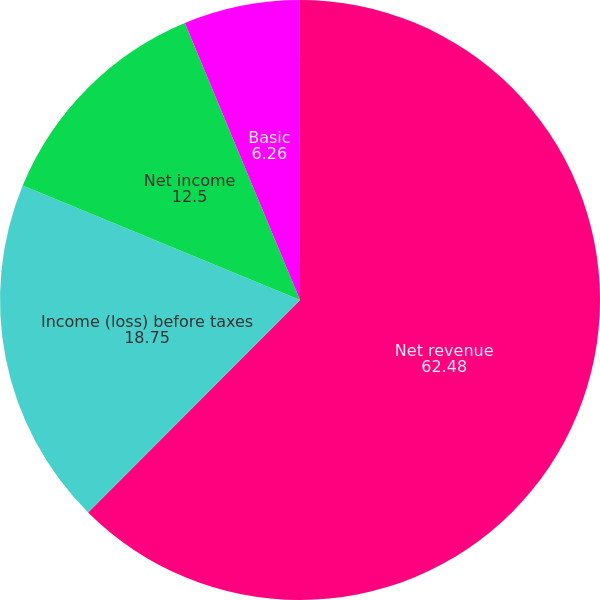<chart> <loc_0><loc_0><loc_500><loc_500><pie_chart><fcel>Net revenue<fcel>Income (loss) before taxes<fcel>Net income<fcel>Basic<fcel>Diluted<nl><fcel>62.48%<fcel>18.75%<fcel>12.5%<fcel>6.26%<fcel>0.01%<nl></chart> 